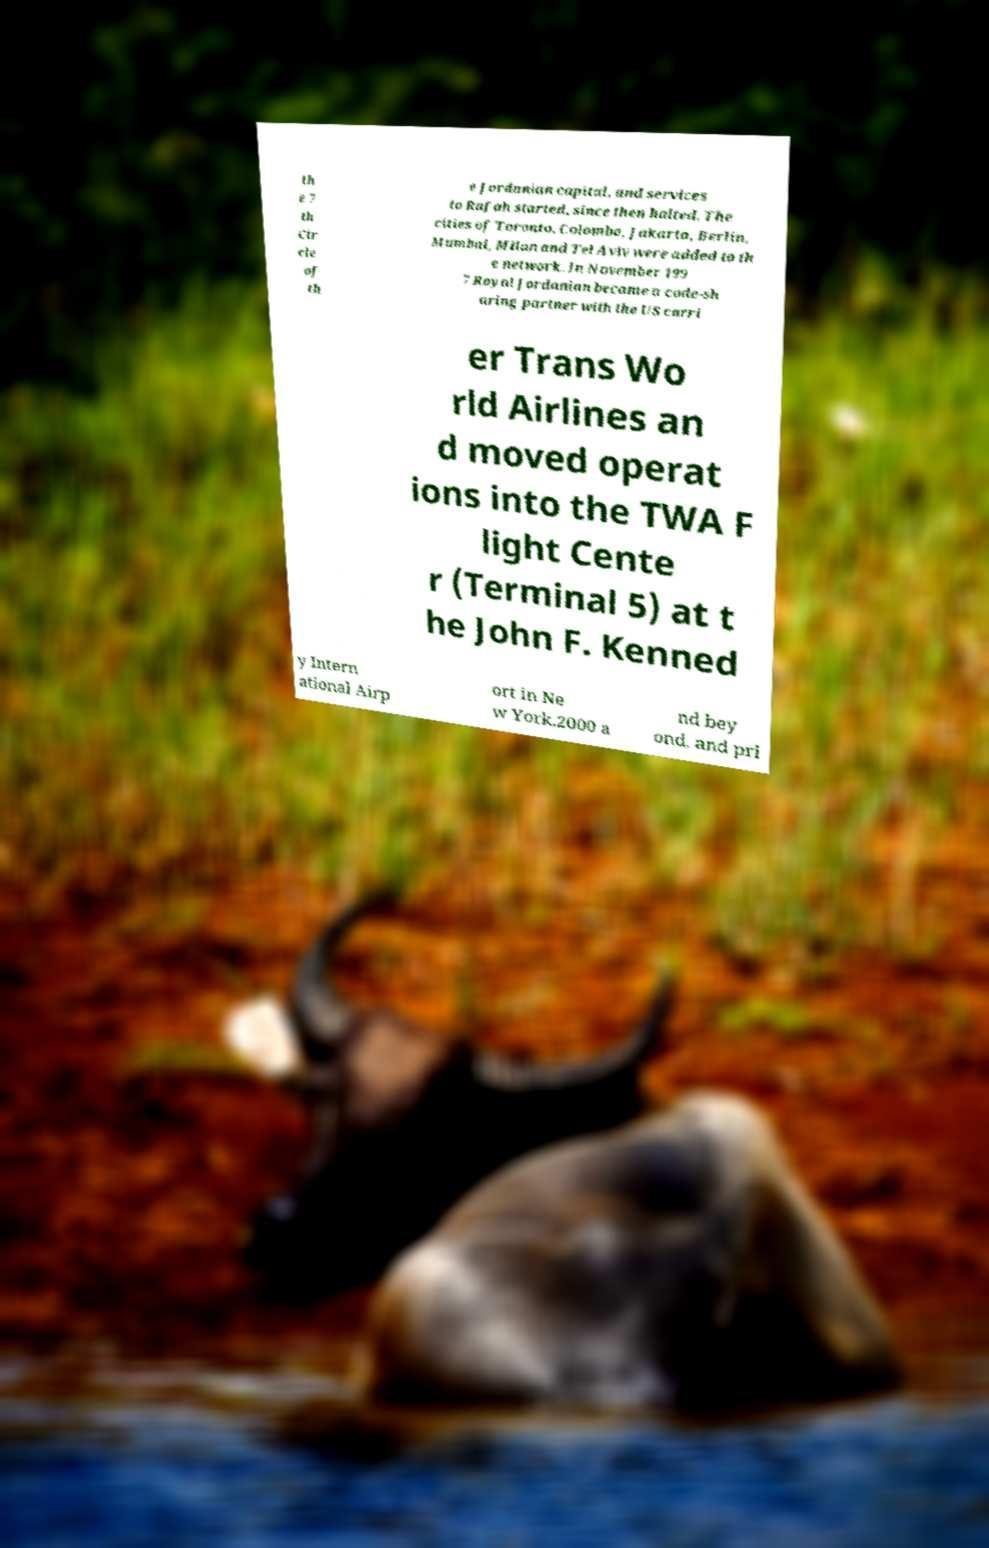Can you accurately transcribe the text from the provided image for me? th e 7 th Cir cle of th e Jordanian capital, and services to Rafah started, since then halted. The cities of Toronto, Colombo, Jakarta, Berlin, Mumbai, Milan and Tel Aviv were added to th e network. In November 199 7 Royal Jordanian became a code-sh aring partner with the US carri er Trans Wo rld Airlines an d moved operat ions into the TWA F light Cente r (Terminal 5) at t he John F. Kenned y Intern ational Airp ort in Ne w York.2000 a nd bey ond, and pri 